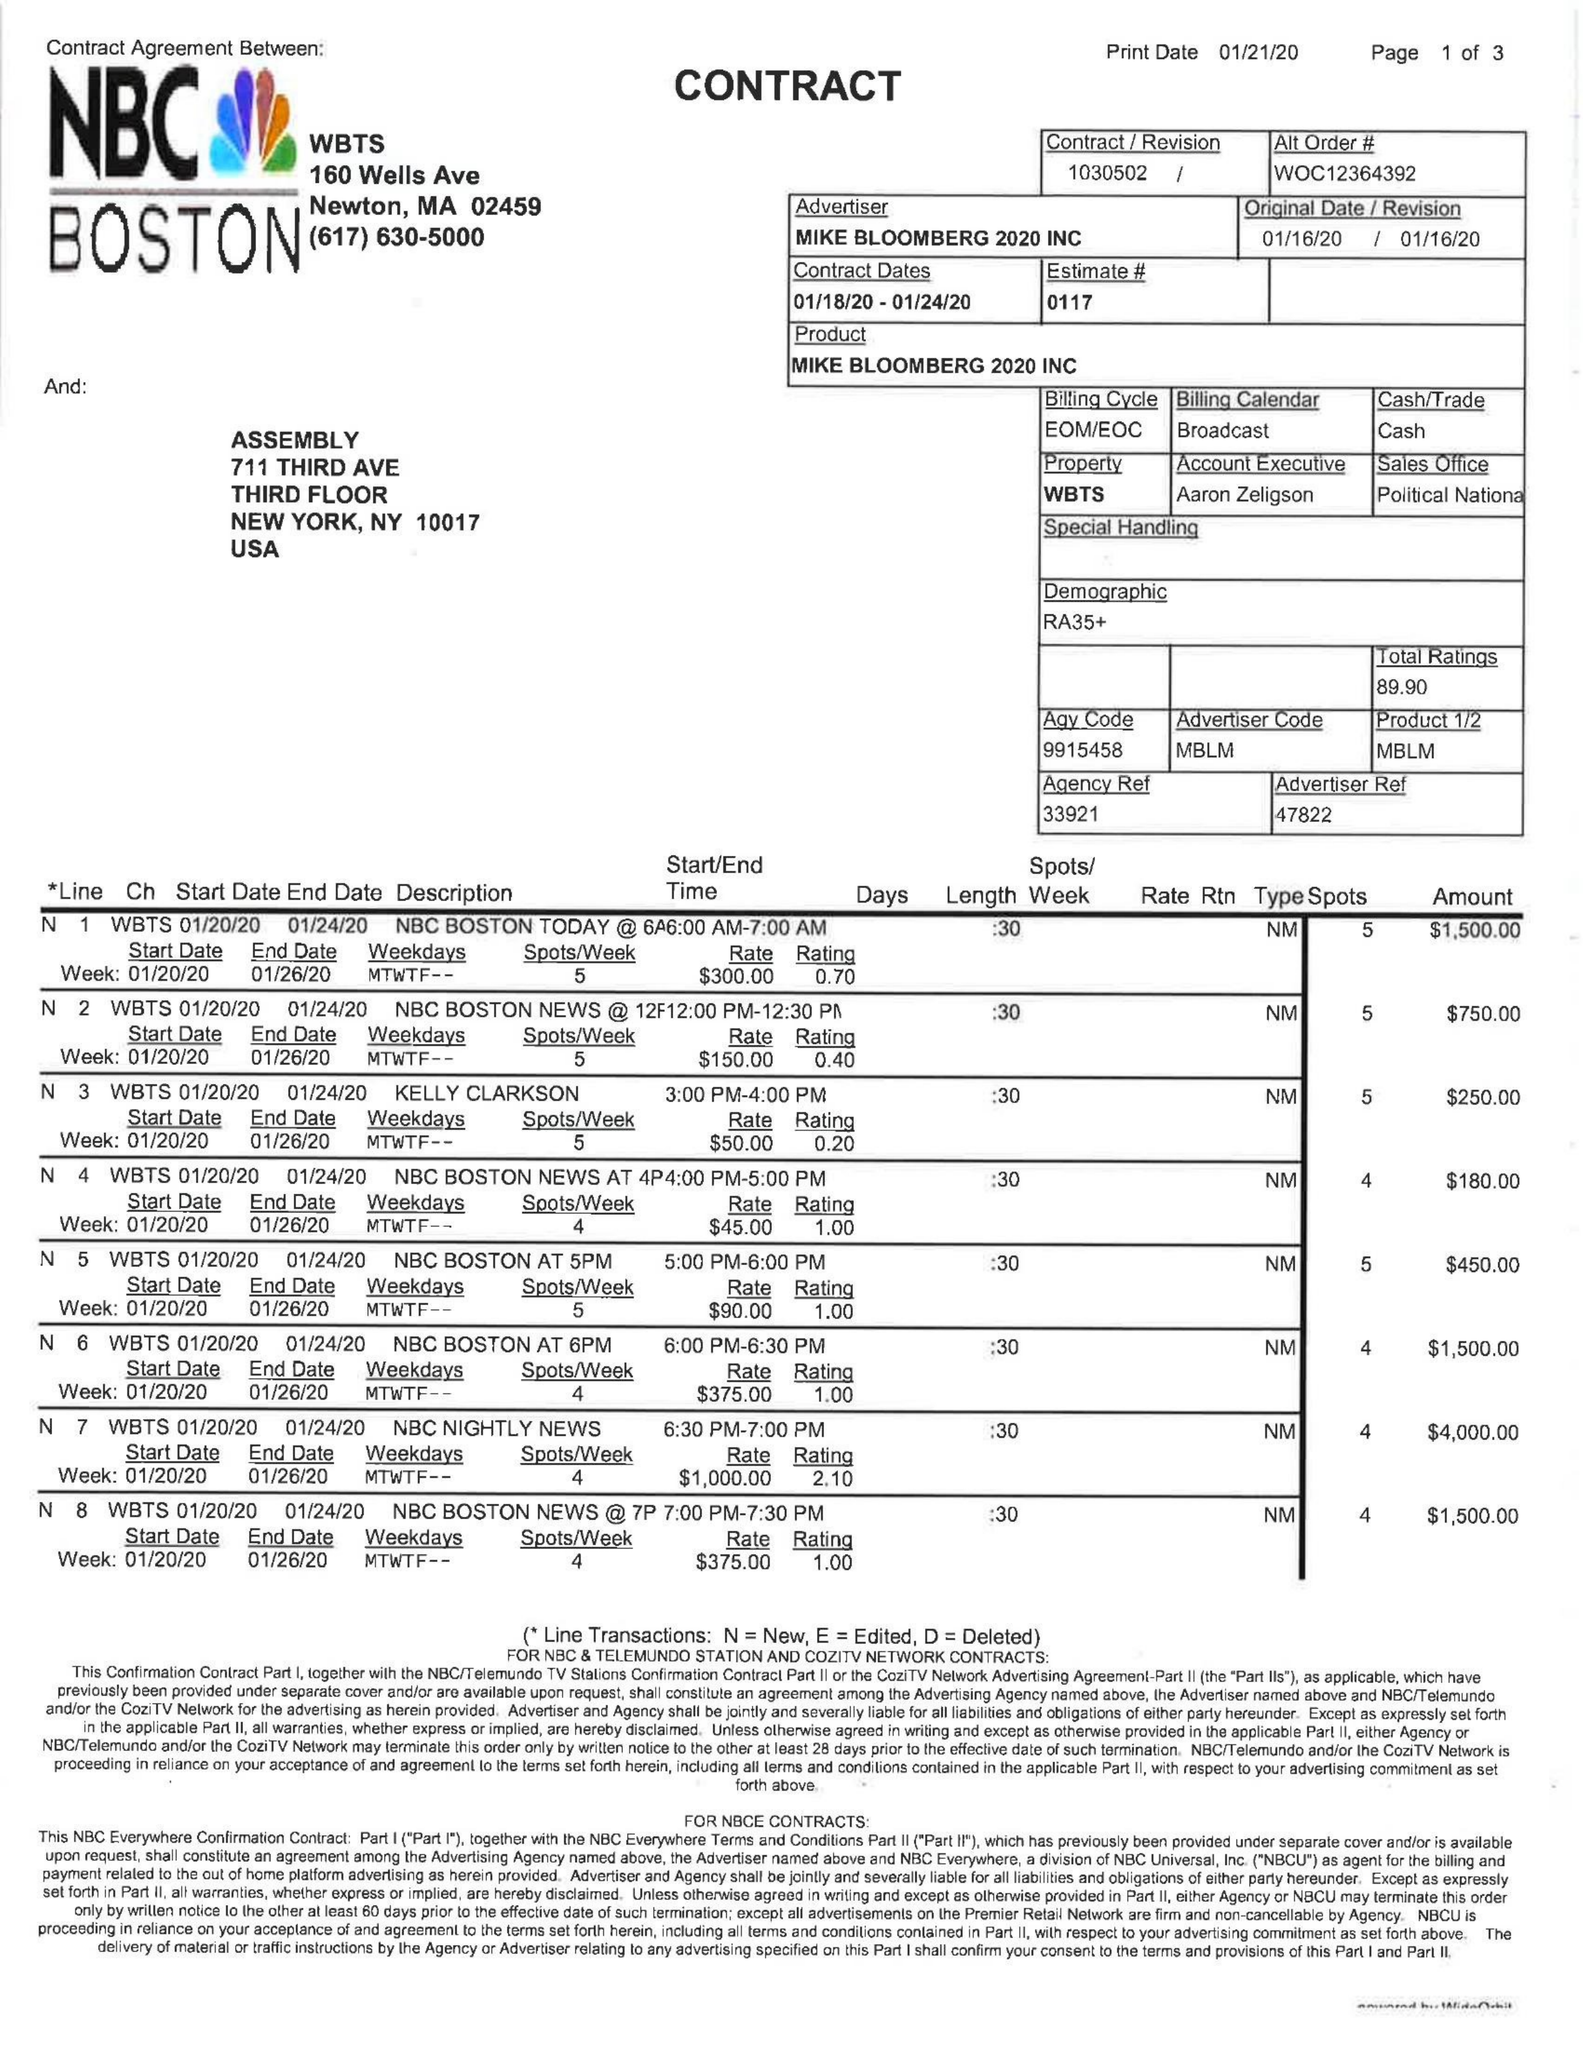What is the value for the flight_to?
Answer the question using a single word or phrase. 01/24/20 